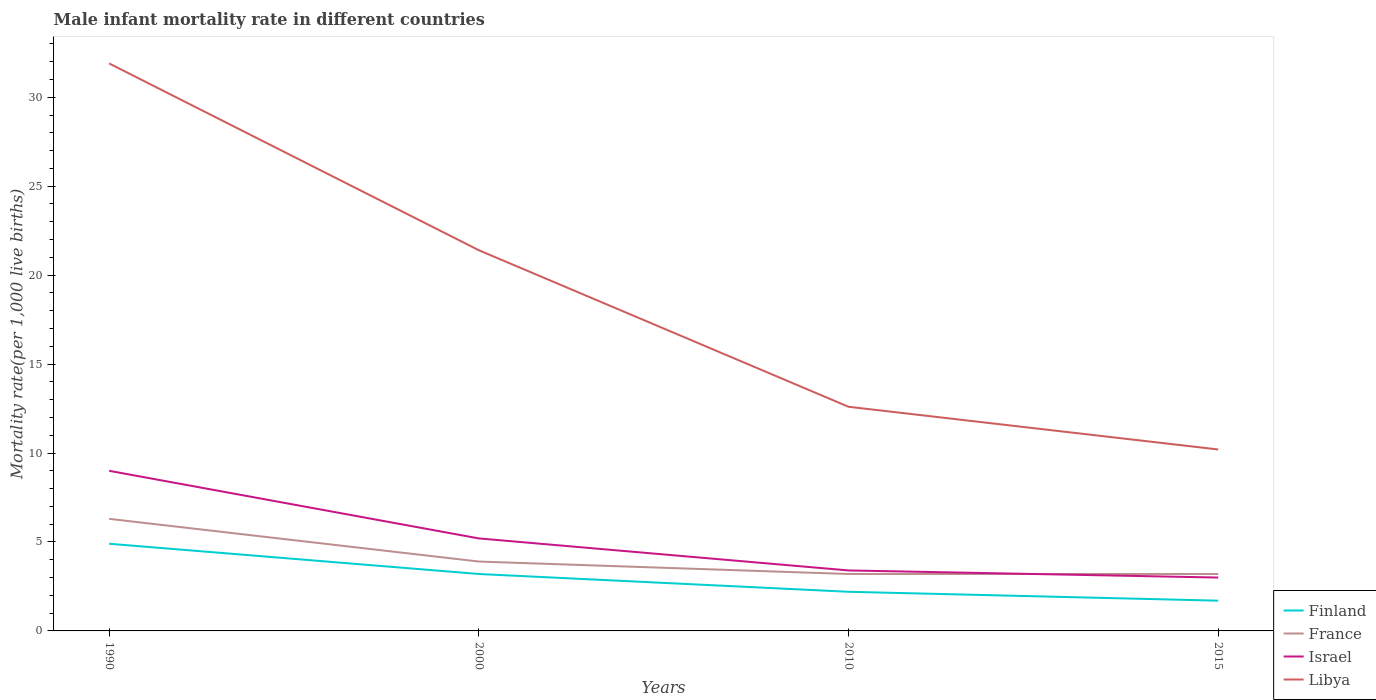Across all years, what is the maximum male infant mortality rate in Libya?
Your response must be concise. 10.2. In which year was the male infant mortality rate in Israel maximum?
Your answer should be compact. 2015. What is the total male infant mortality rate in Israel in the graph?
Provide a short and direct response. 0.4. What is the difference between the highest and the second highest male infant mortality rate in France?
Provide a succinct answer. 3.1. Is the male infant mortality rate in Finland strictly greater than the male infant mortality rate in Libya over the years?
Your response must be concise. Yes. How many lines are there?
Make the answer very short. 4. How many years are there in the graph?
Keep it short and to the point. 4. Does the graph contain grids?
Make the answer very short. No. Where does the legend appear in the graph?
Make the answer very short. Bottom right. What is the title of the graph?
Ensure brevity in your answer.  Male infant mortality rate in different countries. Does "Namibia" appear as one of the legend labels in the graph?
Make the answer very short. No. What is the label or title of the Y-axis?
Provide a short and direct response. Mortality rate(per 1,0 live births). What is the Mortality rate(per 1,000 live births) of France in 1990?
Keep it short and to the point. 6.3. What is the Mortality rate(per 1,000 live births) in Israel in 1990?
Provide a short and direct response. 9. What is the Mortality rate(per 1,000 live births) in Libya in 1990?
Your answer should be very brief. 31.9. What is the Mortality rate(per 1,000 live births) of Finland in 2000?
Keep it short and to the point. 3.2. What is the Mortality rate(per 1,000 live births) of France in 2000?
Your answer should be very brief. 3.9. What is the Mortality rate(per 1,000 live births) in Israel in 2000?
Offer a very short reply. 5.2. What is the Mortality rate(per 1,000 live births) in Libya in 2000?
Your response must be concise. 21.4. What is the Mortality rate(per 1,000 live births) of France in 2010?
Give a very brief answer. 3.2. What is the Mortality rate(per 1,000 live births) in Finland in 2015?
Keep it short and to the point. 1.7. What is the Mortality rate(per 1,000 live births) of France in 2015?
Offer a very short reply. 3.2. What is the Mortality rate(per 1,000 live births) in Libya in 2015?
Give a very brief answer. 10.2. Across all years, what is the maximum Mortality rate(per 1,000 live births) in Israel?
Give a very brief answer. 9. Across all years, what is the maximum Mortality rate(per 1,000 live births) in Libya?
Ensure brevity in your answer.  31.9. What is the total Mortality rate(per 1,000 live births) in Finland in the graph?
Keep it short and to the point. 12. What is the total Mortality rate(per 1,000 live births) in Israel in the graph?
Keep it short and to the point. 20.6. What is the total Mortality rate(per 1,000 live births) in Libya in the graph?
Your answer should be very brief. 76.1. What is the difference between the Mortality rate(per 1,000 live births) of Finland in 1990 and that in 2000?
Provide a short and direct response. 1.7. What is the difference between the Mortality rate(per 1,000 live births) in Libya in 1990 and that in 2000?
Make the answer very short. 10.5. What is the difference between the Mortality rate(per 1,000 live births) in France in 1990 and that in 2010?
Offer a very short reply. 3.1. What is the difference between the Mortality rate(per 1,000 live births) in Israel in 1990 and that in 2010?
Offer a very short reply. 5.6. What is the difference between the Mortality rate(per 1,000 live births) in Libya in 1990 and that in 2010?
Offer a very short reply. 19.3. What is the difference between the Mortality rate(per 1,000 live births) of France in 1990 and that in 2015?
Ensure brevity in your answer.  3.1. What is the difference between the Mortality rate(per 1,000 live births) in Libya in 1990 and that in 2015?
Offer a very short reply. 21.7. What is the difference between the Mortality rate(per 1,000 live births) in Finland in 2000 and that in 2010?
Ensure brevity in your answer.  1. What is the difference between the Mortality rate(per 1,000 live births) of France in 2000 and that in 2010?
Offer a very short reply. 0.7. What is the difference between the Mortality rate(per 1,000 live births) of Libya in 2000 and that in 2010?
Provide a succinct answer. 8.8. What is the difference between the Mortality rate(per 1,000 live births) of Finland in 2000 and that in 2015?
Provide a succinct answer. 1.5. What is the difference between the Mortality rate(per 1,000 live births) in Israel in 2010 and that in 2015?
Your answer should be very brief. 0.4. What is the difference between the Mortality rate(per 1,000 live births) of Libya in 2010 and that in 2015?
Your response must be concise. 2.4. What is the difference between the Mortality rate(per 1,000 live births) in Finland in 1990 and the Mortality rate(per 1,000 live births) in France in 2000?
Your answer should be very brief. 1. What is the difference between the Mortality rate(per 1,000 live births) in Finland in 1990 and the Mortality rate(per 1,000 live births) in Israel in 2000?
Provide a short and direct response. -0.3. What is the difference between the Mortality rate(per 1,000 live births) in Finland in 1990 and the Mortality rate(per 1,000 live births) in Libya in 2000?
Your answer should be compact. -16.5. What is the difference between the Mortality rate(per 1,000 live births) of France in 1990 and the Mortality rate(per 1,000 live births) of Israel in 2000?
Your answer should be compact. 1.1. What is the difference between the Mortality rate(per 1,000 live births) of France in 1990 and the Mortality rate(per 1,000 live births) of Libya in 2000?
Keep it short and to the point. -15.1. What is the difference between the Mortality rate(per 1,000 live births) of Finland in 1990 and the Mortality rate(per 1,000 live births) of France in 2010?
Provide a short and direct response. 1.7. What is the difference between the Mortality rate(per 1,000 live births) of Finland in 1990 and the Mortality rate(per 1,000 live births) of Israel in 2015?
Ensure brevity in your answer.  1.9. What is the difference between the Mortality rate(per 1,000 live births) in France in 1990 and the Mortality rate(per 1,000 live births) in Libya in 2015?
Your answer should be very brief. -3.9. What is the difference between the Mortality rate(per 1,000 live births) of Finland in 2000 and the Mortality rate(per 1,000 live births) of Libya in 2010?
Provide a succinct answer. -9.4. What is the difference between the Mortality rate(per 1,000 live births) in France in 2000 and the Mortality rate(per 1,000 live births) in Israel in 2010?
Keep it short and to the point. 0.5. What is the difference between the Mortality rate(per 1,000 live births) of France in 2000 and the Mortality rate(per 1,000 live births) of Libya in 2010?
Offer a terse response. -8.7. What is the difference between the Mortality rate(per 1,000 live births) in Finland in 2000 and the Mortality rate(per 1,000 live births) in France in 2015?
Your answer should be compact. 0. What is the difference between the Mortality rate(per 1,000 live births) in France in 2000 and the Mortality rate(per 1,000 live births) in Israel in 2015?
Ensure brevity in your answer.  0.9. What is the difference between the Mortality rate(per 1,000 live births) of France in 2000 and the Mortality rate(per 1,000 live births) of Libya in 2015?
Offer a very short reply. -6.3. What is the difference between the Mortality rate(per 1,000 live births) of Finland in 2010 and the Mortality rate(per 1,000 live births) of France in 2015?
Give a very brief answer. -1. What is the average Mortality rate(per 1,000 live births) of France per year?
Keep it short and to the point. 4.15. What is the average Mortality rate(per 1,000 live births) in Israel per year?
Keep it short and to the point. 5.15. What is the average Mortality rate(per 1,000 live births) of Libya per year?
Make the answer very short. 19.02. In the year 1990, what is the difference between the Mortality rate(per 1,000 live births) of Finland and Mortality rate(per 1,000 live births) of Libya?
Provide a short and direct response. -27. In the year 1990, what is the difference between the Mortality rate(per 1,000 live births) in France and Mortality rate(per 1,000 live births) in Israel?
Your response must be concise. -2.7. In the year 1990, what is the difference between the Mortality rate(per 1,000 live births) of France and Mortality rate(per 1,000 live births) of Libya?
Offer a terse response. -25.6. In the year 1990, what is the difference between the Mortality rate(per 1,000 live births) of Israel and Mortality rate(per 1,000 live births) of Libya?
Keep it short and to the point. -22.9. In the year 2000, what is the difference between the Mortality rate(per 1,000 live births) of Finland and Mortality rate(per 1,000 live births) of Libya?
Provide a succinct answer. -18.2. In the year 2000, what is the difference between the Mortality rate(per 1,000 live births) in France and Mortality rate(per 1,000 live births) in Libya?
Your answer should be compact. -17.5. In the year 2000, what is the difference between the Mortality rate(per 1,000 live births) in Israel and Mortality rate(per 1,000 live births) in Libya?
Offer a very short reply. -16.2. In the year 2010, what is the difference between the Mortality rate(per 1,000 live births) in France and Mortality rate(per 1,000 live births) in Libya?
Provide a short and direct response. -9.4. In the year 2010, what is the difference between the Mortality rate(per 1,000 live births) of Israel and Mortality rate(per 1,000 live births) of Libya?
Your answer should be very brief. -9.2. In the year 2015, what is the difference between the Mortality rate(per 1,000 live births) in Finland and Mortality rate(per 1,000 live births) in Libya?
Offer a terse response. -8.5. In the year 2015, what is the difference between the Mortality rate(per 1,000 live births) in France and Mortality rate(per 1,000 live births) in Israel?
Provide a short and direct response. 0.2. In the year 2015, what is the difference between the Mortality rate(per 1,000 live births) in France and Mortality rate(per 1,000 live births) in Libya?
Offer a very short reply. -7. What is the ratio of the Mortality rate(per 1,000 live births) in Finland in 1990 to that in 2000?
Keep it short and to the point. 1.53. What is the ratio of the Mortality rate(per 1,000 live births) in France in 1990 to that in 2000?
Offer a terse response. 1.62. What is the ratio of the Mortality rate(per 1,000 live births) of Israel in 1990 to that in 2000?
Your answer should be very brief. 1.73. What is the ratio of the Mortality rate(per 1,000 live births) of Libya in 1990 to that in 2000?
Provide a short and direct response. 1.49. What is the ratio of the Mortality rate(per 1,000 live births) in Finland in 1990 to that in 2010?
Keep it short and to the point. 2.23. What is the ratio of the Mortality rate(per 1,000 live births) of France in 1990 to that in 2010?
Your response must be concise. 1.97. What is the ratio of the Mortality rate(per 1,000 live births) of Israel in 1990 to that in 2010?
Offer a very short reply. 2.65. What is the ratio of the Mortality rate(per 1,000 live births) of Libya in 1990 to that in 2010?
Your answer should be compact. 2.53. What is the ratio of the Mortality rate(per 1,000 live births) in Finland in 1990 to that in 2015?
Your answer should be very brief. 2.88. What is the ratio of the Mortality rate(per 1,000 live births) of France in 1990 to that in 2015?
Offer a terse response. 1.97. What is the ratio of the Mortality rate(per 1,000 live births) of Israel in 1990 to that in 2015?
Provide a succinct answer. 3. What is the ratio of the Mortality rate(per 1,000 live births) in Libya in 1990 to that in 2015?
Provide a succinct answer. 3.13. What is the ratio of the Mortality rate(per 1,000 live births) in Finland in 2000 to that in 2010?
Your answer should be compact. 1.45. What is the ratio of the Mortality rate(per 1,000 live births) of France in 2000 to that in 2010?
Your answer should be very brief. 1.22. What is the ratio of the Mortality rate(per 1,000 live births) of Israel in 2000 to that in 2010?
Offer a very short reply. 1.53. What is the ratio of the Mortality rate(per 1,000 live births) of Libya in 2000 to that in 2010?
Your response must be concise. 1.7. What is the ratio of the Mortality rate(per 1,000 live births) in Finland in 2000 to that in 2015?
Offer a very short reply. 1.88. What is the ratio of the Mortality rate(per 1,000 live births) in France in 2000 to that in 2015?
Your answer should be compact. 1.22. What is the ratio of the Mortality rate(per 1,000 live births) in Israel in 2000 to that in 2015?
Make the answer very short. 1.73. What is the ratio of the Mortality rate(per 1,000 live births) in Libya in 2000 to that in 2015?
Your response must be concise. 2.1. What is the ratio of the Mortality rate(per 1,000 live births) of Finland in 2010 to that in 2015?
Offer a terse response. 1.29. What is the ratio of the Mortality rate(per 1,000 live births) of Israel in 2010 to that in 2015?
Offer a terse response. 1.13. What is the ratio of the Mortality rate(per 1,000 live births) in Libya in 2010 to that in 2015?
Give a very brief answer. 1.24. What is the difference between the highest and the second highest Mortality rate(per 1,000 live births) of France?
Offer a terse response. 2.4. What is the difference between the highest and the second highest Mortality rate(per 1,000 live births) of Libya?
Give a very brief answer. 10.5. What is the difference between the highest and the lowest Mortality rate(per 1,000 live births) in Israel?
Provide a short and direct response. 6. What is the difference between the highest and the lowest Mortality rate(per 1,000 live births) of Libya?
Offer a very short reply. 21.7. 